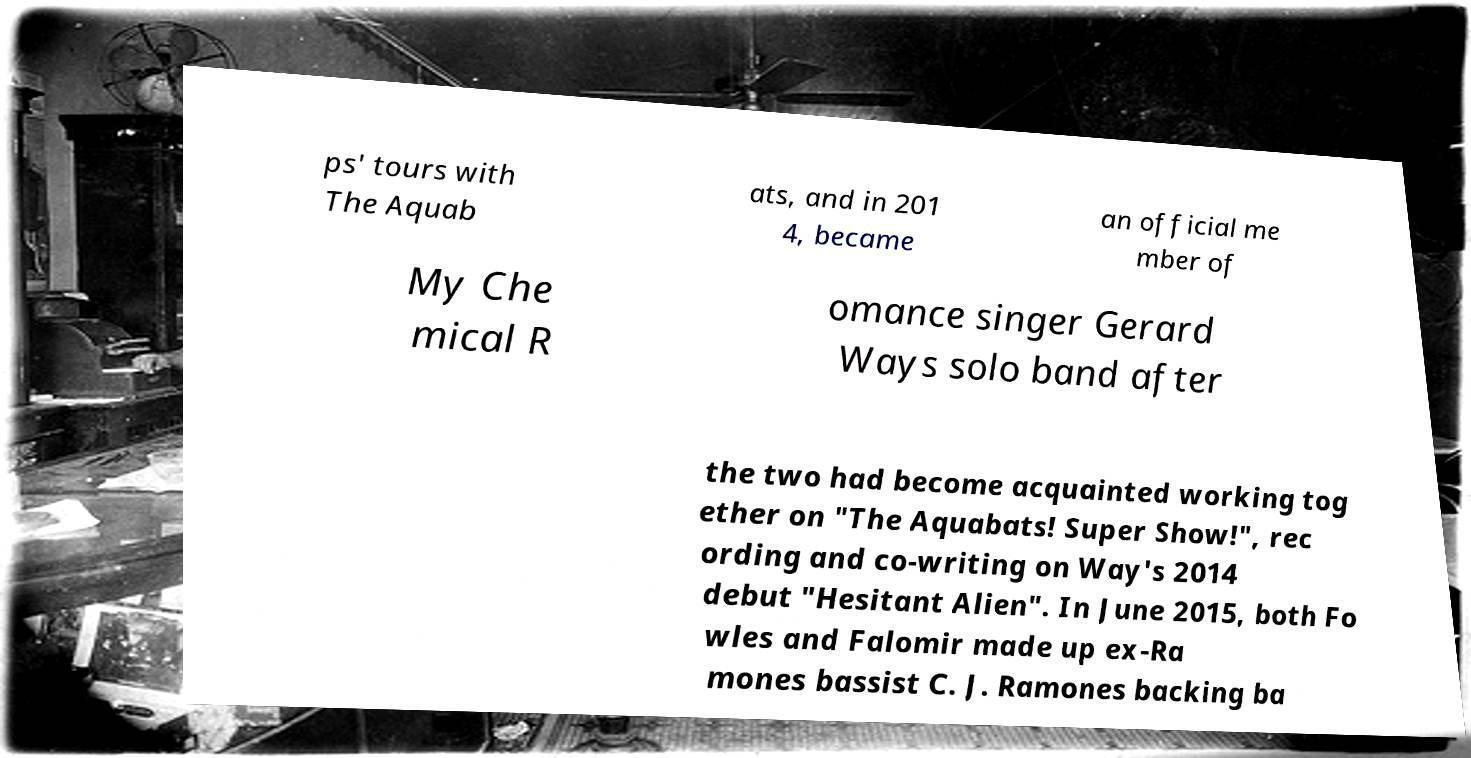I need the written content from this picture converted into text. Can you do that? ps' tours with The Aquab ats, and in 201 4, became an official me mber of My Che mical R omance singer Gerard Ways solo band after the two had become acquainted working tog ether on "The Aquabats! Super Show!", rec ording and co-writing on Way's 2014 debut "Hesitant Alien". In June 2015, both Fo wles and Falomir made up ex-Ra mones bassist C. J. Ramones backing ba 